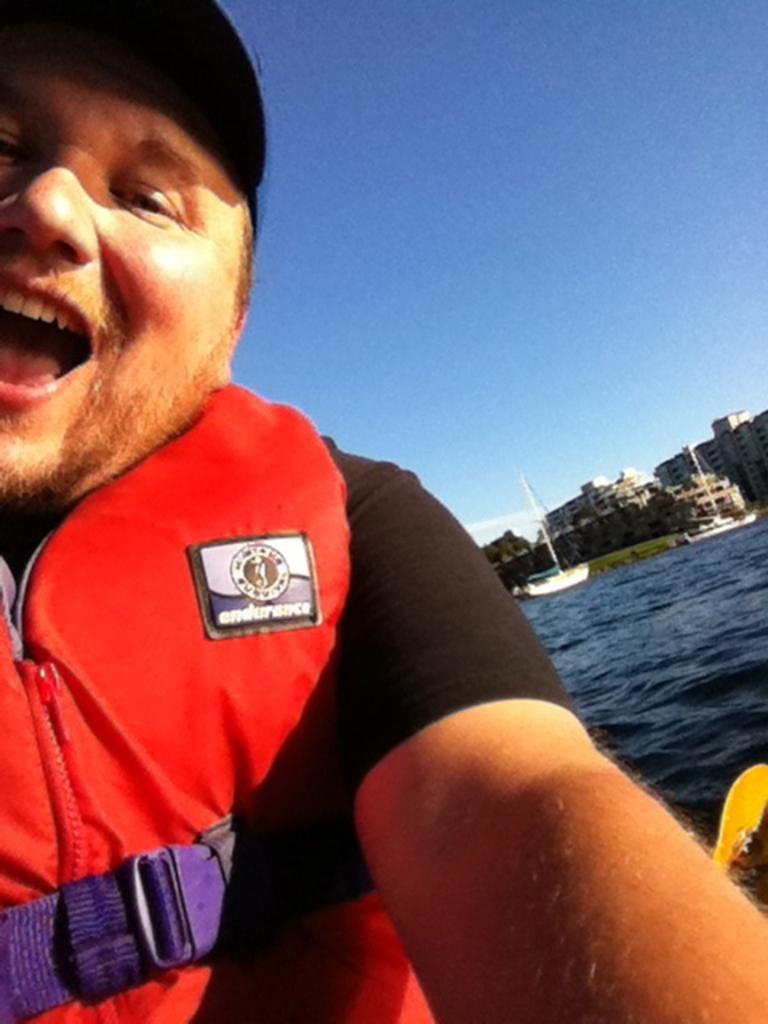Describe this image in one or two sentences. This image consists of a man wearing a red jacket. At the bottom, we can see water. In the background, there are boats along with buildings. At the top, there is sky. 